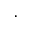Convert formula to latex. <formula><loc_0><loc_0><loc_500><loc_500>\cdot</formula> 